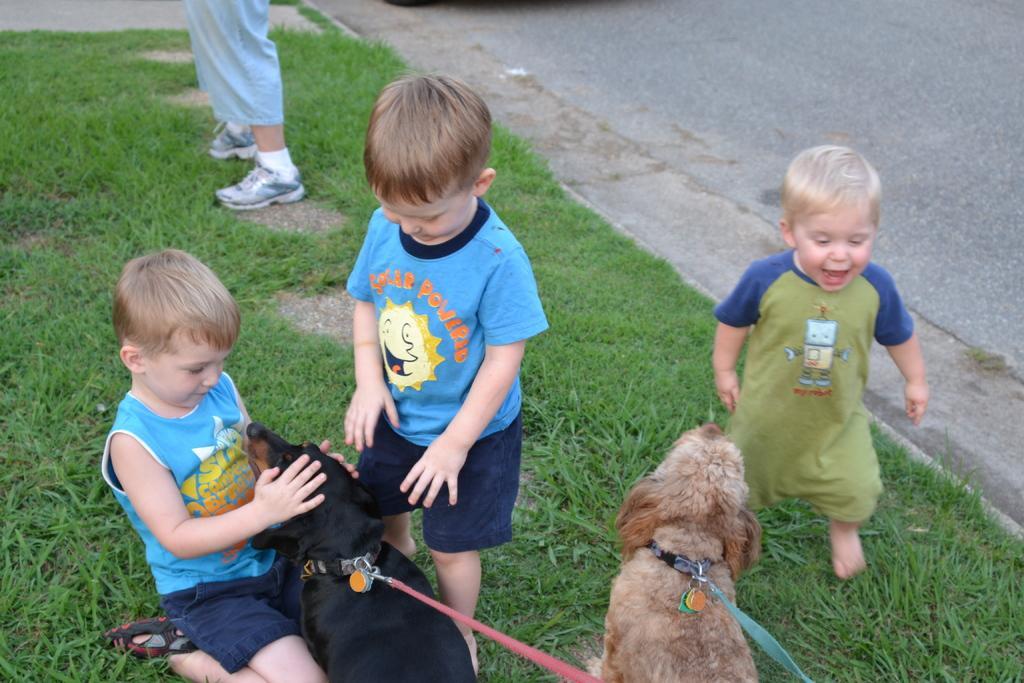In one or two sentences, can you explain what this image depicts? there are 2 dogs. in front of them there are 4 people on the grass. on the right there is road. 